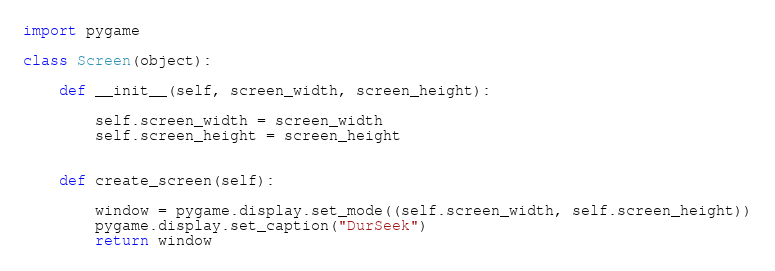<code> <loc_0><loc_0><loc_500><loc_500><_Python_>import pygame

class Screen(object):

    def __init__(self, screen_width, screen_height):

        self.screen_width = screen_width
        self.screen_height = screen_height
    

    def create_screen(self):

        window = pygame.display.set_mode((self.screen_width, self.screen_height))
        pygame.display.set_caption("DurSeek")
        return window
</code> 